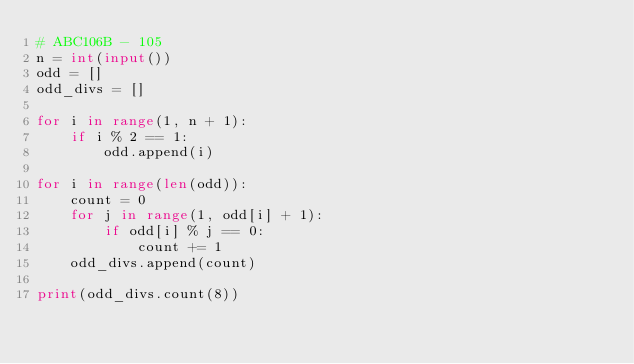Convert code to text. <code><loc_0><loc_0><loc_500><loc_500><_Python_># ABC106B - 105
n = int(input())
odd = []
odd_divs = []

for i in range(1, n + 1):
    if i % 2 == 1:
        odd.append(i)
        
for i in range(len(odd)):
    count = 0
    for j in range(1, odd[i] + 1):
        if odd[i] % j == 0:
            count += 1            
    odd_divs.append(count)
    
print(odd_divs.count(8))</code> 